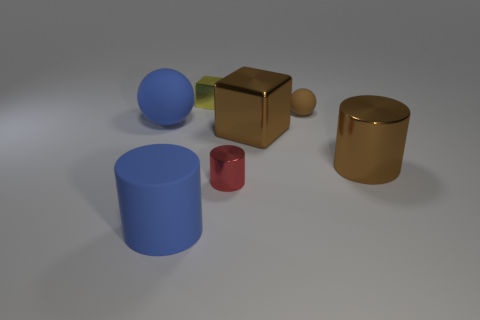Subtract all brown cylinders. How many cylinders are left? 2 Subtract all brown cylinders. How many cylinders are left? 2 Subtract 2 spheres. How many spheres are left? 0 Subtract all brown spheres. How many blue cylinders are left? 1 Subtract all large metal things. Subtract all large matte spheres. How many objects are left? 4 Add 5 rubber things. How many rubber things are left? 8 Add 2 yellow shiny things. How many yellow shiny things exist? 3 Add 1 purple shiny objects. How many objects exist? 8 Subtract 0 gray cylinders. How many objects are left? 7 Subtract all cylinders. How many objects are left? 4 